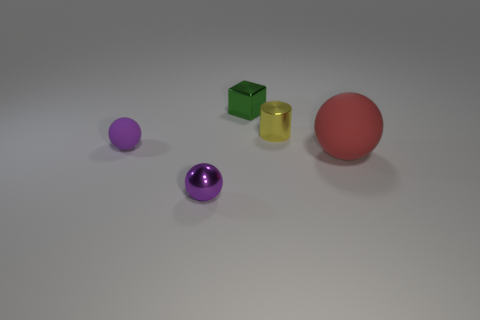Are there any other things that are the same shape as the yellow shiny object?
Ensure brevity in your answer.  No. Do the metal object that is in front of the small metallic cylinder and the small sphere that is behind the large red thing have the same color?
Offer a very short reply. Yes. Are any metallic objects visible?
Your answer should be compact. Yes. There is a tiny thing that is the same color as the metal ball; what is it made of?
Keep it short and to the point. Rubber. There is a rubber ball that is in front of the purple ball that is behind the object in front of the large red matte ball; what size is it?
Ensure brevity in your answer.  Large. Do the tiny purple rubber object and the rubber thing on the right side of the yellow cylinder have the same shape?
Your response must be concise. Yes. Is there another small sphere of the same color as the shiny ball?
Provide a succinct answer. Yes. What number of balls are small purple metal things or tiny metallic things?
Provide a short and direct response. 1. Is there a small purple shiny thing of the same shape as the large rubber object?
Offer a very short reply. Yes. How many other things are there of the same color as the shiny cylinder?
Your answer should be very brief. 0. 